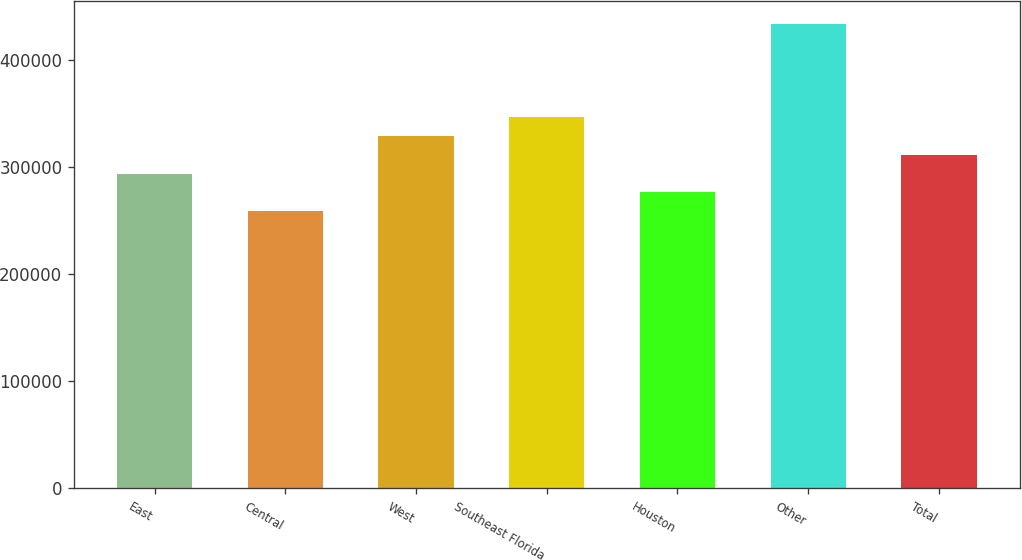Convert chart. <chart><loc_0><loc_0><loc_500><loc_500><bar_chart><fcel>East<fcel>Central<fcel>West<fcel>Southeast Florida<fcel>Houston<fcel>Other<fcel>Total<nl><fcel>294000<fcel>259000<fcel>329000<fcel>346500<fcel>276500<fcel>434000<fcel>311500<nl></chart> 